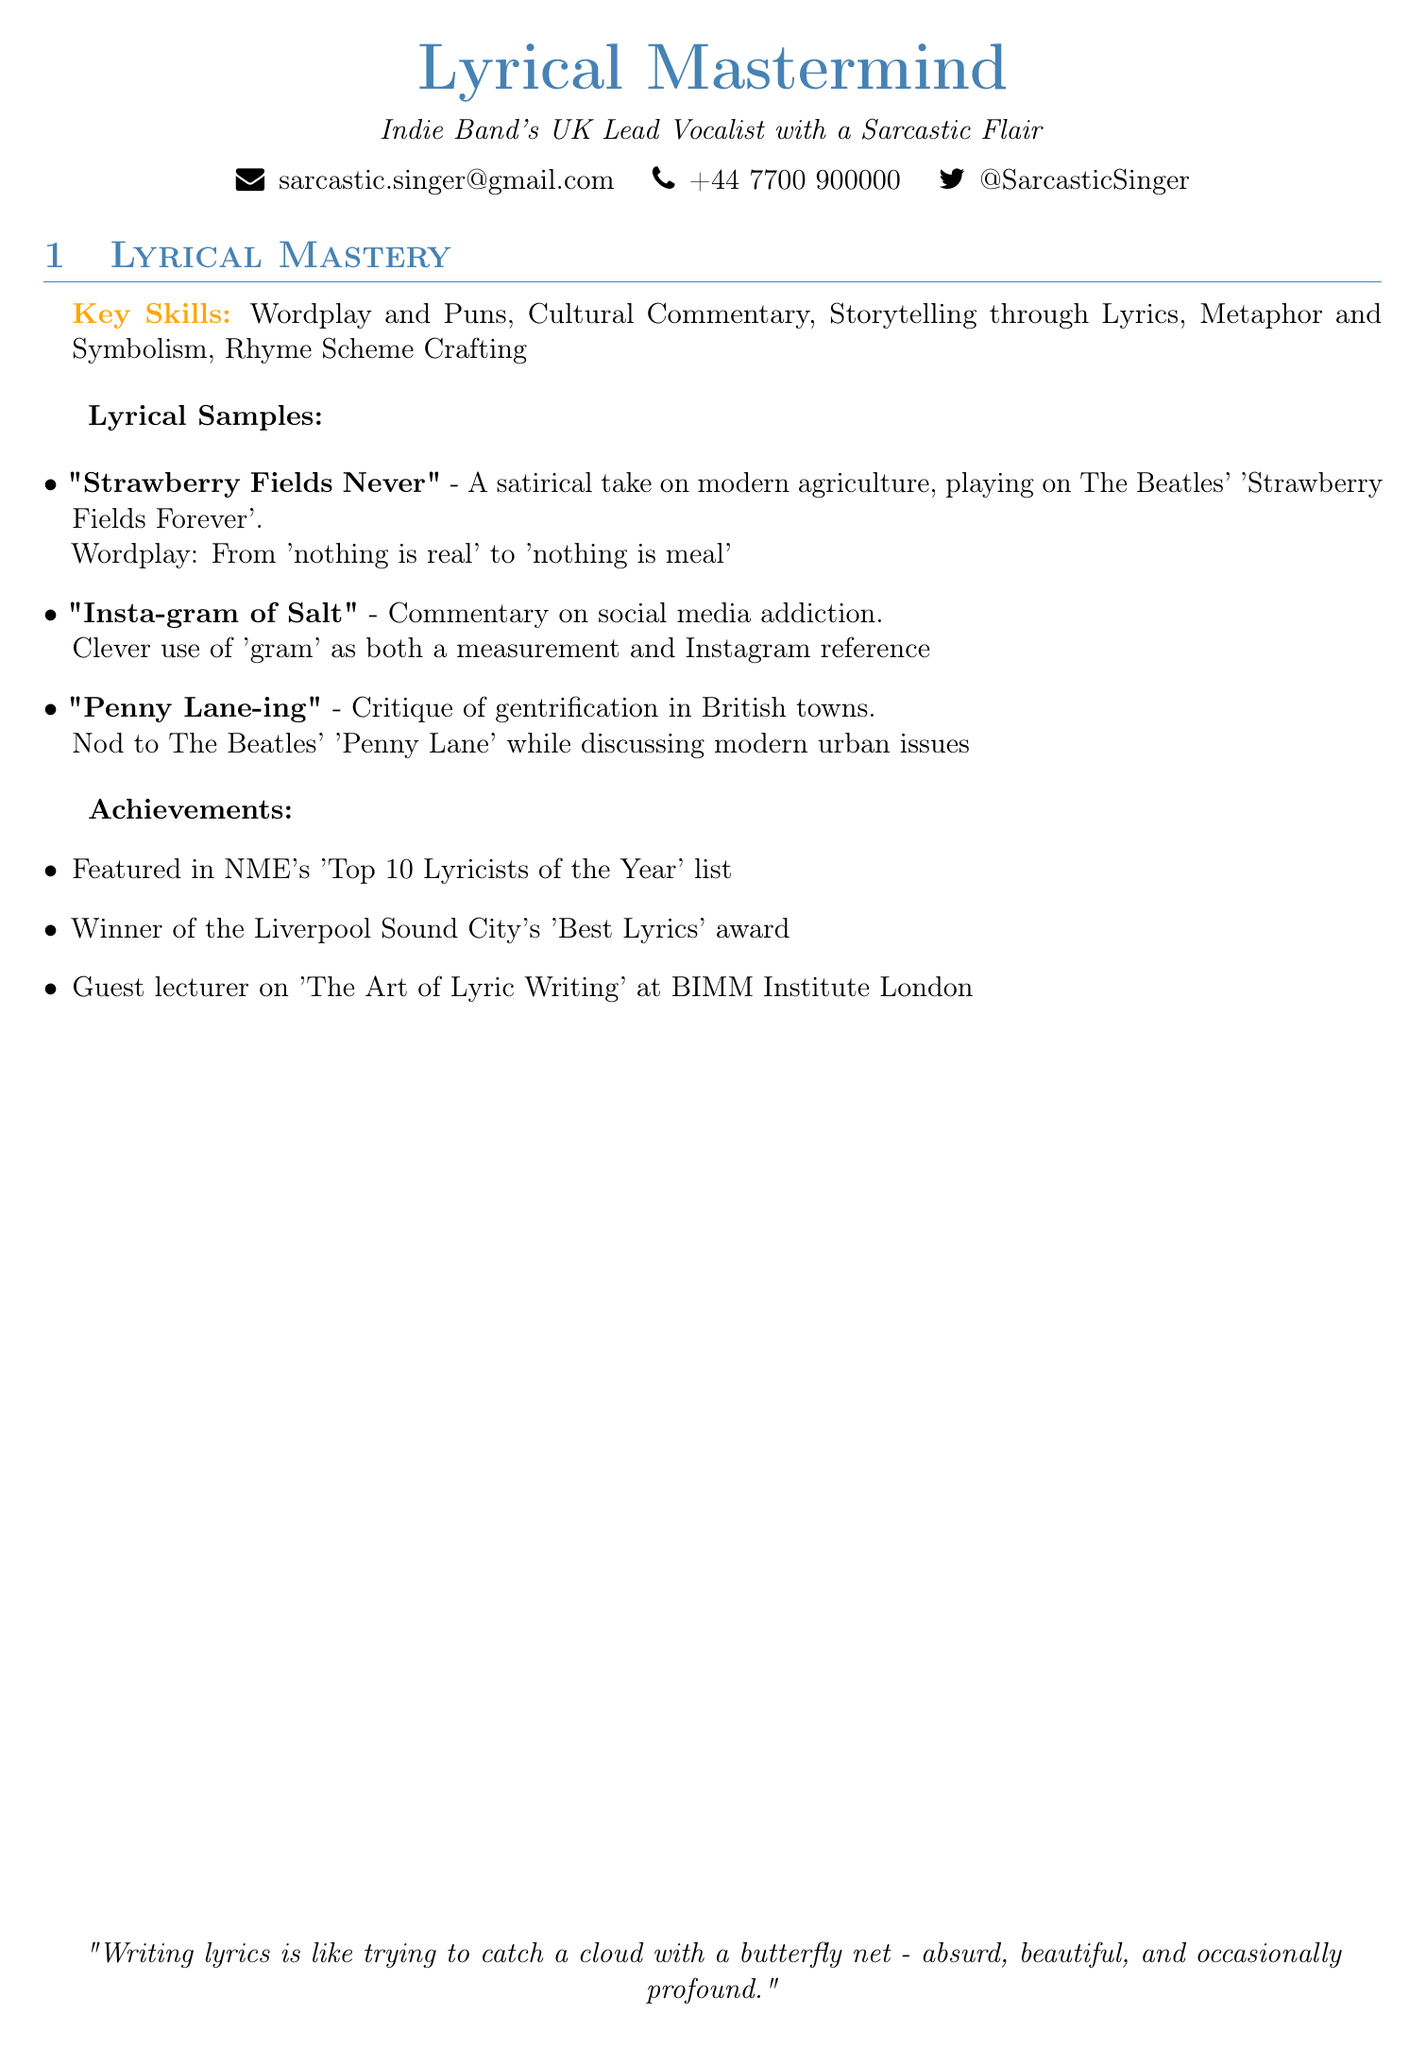what is the title of the skills section? The title of the skills section is specified at the beginning of that section, which is "Lyrical Mastery".
Answer: Lyrical Mastery how many key skills are listed in the document? The document lists a total of five key skills under the skills section.
Answer: 5 what is the first lyrical sample mentioned? The first lyrical sample is identified by the title mentioned at the start of the lyrical samples section.
Answer: Strawberry Fields Never which award did the individual win? The document explicitly mentions one of the achievements as winning the 'Best Lyrics' award at Liverpool Sound City.
Answer: Best Lyrics what type of commentary does "Insta-gram of Salt" provide? The title of this lyrical sample suggests a focus on what aspect of modern society.
Answer: Social media addiction in which city was 'The Art of Lyric Writing' guest lectured? The document specifies the location of the guest lecture, which is particularly noted.
Answer: London what clever phrase is used in "Strawberry Fields Never"? The wordplay mentioned in this sample includes a clever twist on a famous phrase.
Answer: nothing is meal how does the document describe the author's style? The document contains a quotation that reflects on the process of writing lyrics, conveying the author's perspective.
Answer: absurd, beautiful, and occasionally profound 